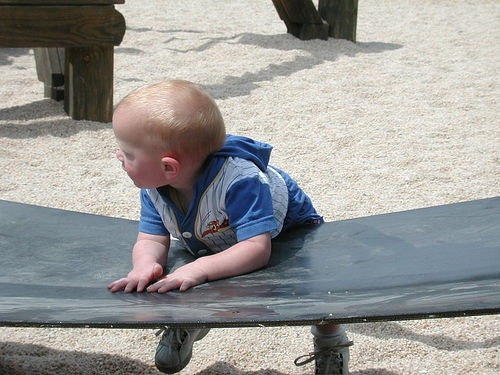Describe the objects in this image and their specific colors. I can see people in black, gray, darkgray, and navy tones and bench in black and gray tones in this image. 